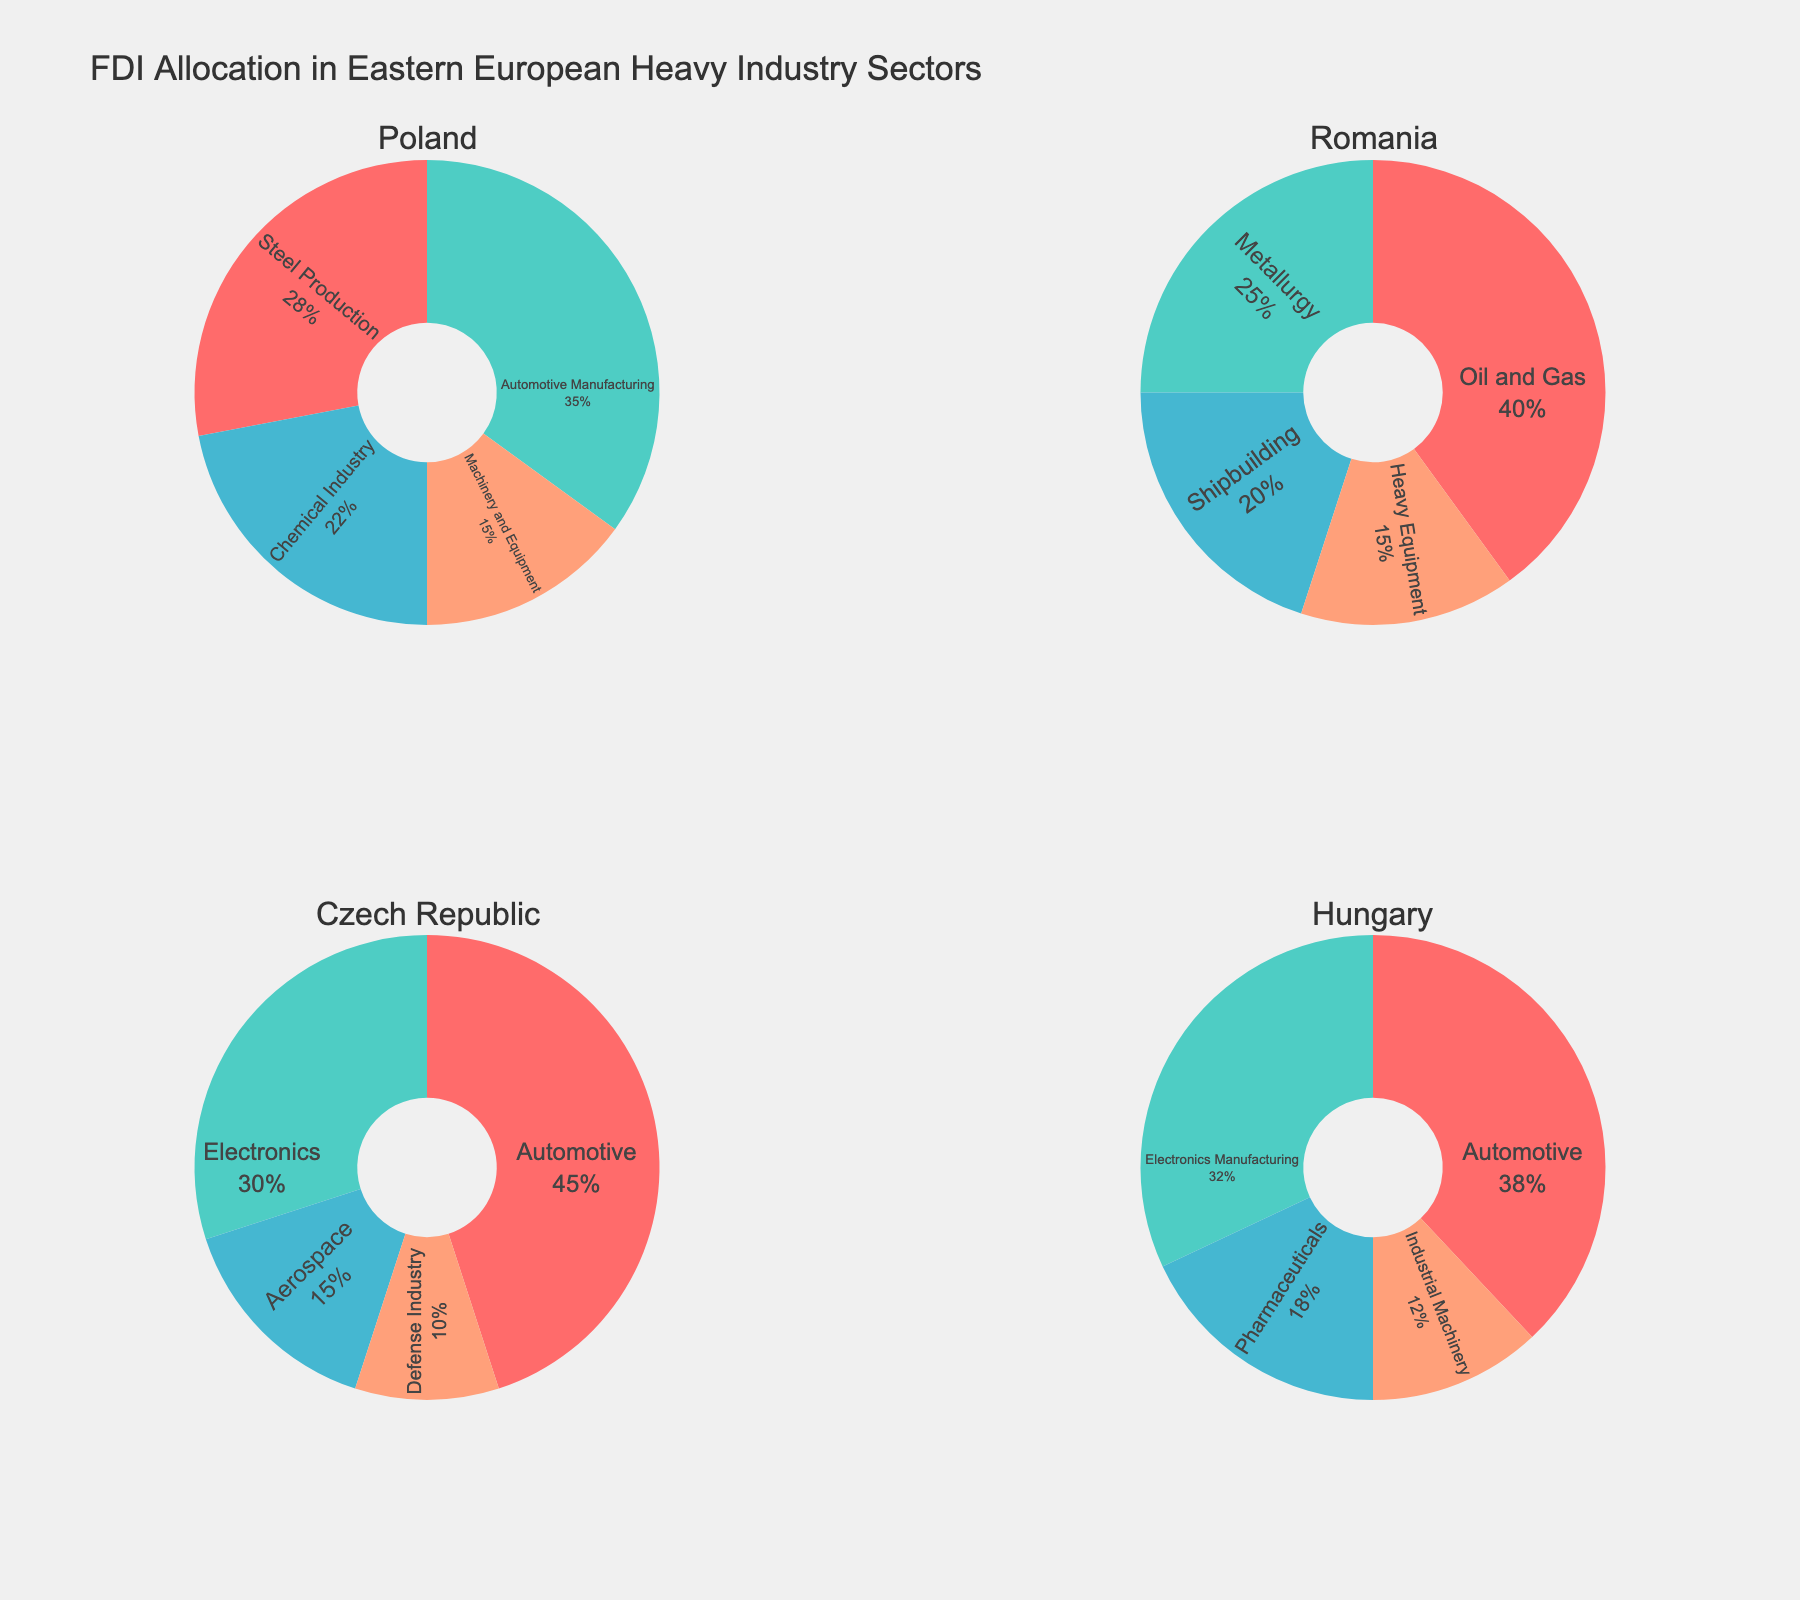What's the title of the figure? The title of the figure is written at the top center of the plot. It reads, "FDI Allocation in Eastern European Heavy Industry Sectors."
Answer: FDI Allocation in Eastern European Heavy Industry Sectors Which country has the highest allocation for a single sector, and what is the sector? By examining the pie charts, we observe that the Czech Republic has the highest allocation for the Automotive sector at 45%.
Answer: Czech Republic, Automotive What's the combined FDI allocation percentage for the Chemical Industry and Heavy Equipment sectors in Poland? We sum the percentages for the Chemical Industry (22%) and Heavy Equipment (15%) sectors in Poland. The combined allocation is 22% + 15% = 37%.
Answer: 37% Which sector receives the least FDI allocation in Hungary? By looking at the pie chart for Hungary, we notice that the Industrial Machinery sector receives the least FDI allocation at 12%.
Answer: Industrial Machinery How does the FDI allocation for the Automotive sector in the Czech Republic compare with that in Poland and Hungary? The FDI allocation in the Automotive sector is 45% in the Czech Republic, 35% in Poland, and 38% in Hungary. The Czech Republic has the highest allocation, followed by Hungary, and then Poland.
Answer: Highest in the Czech Republic, followed by Hungary, then Poland Which country has the most diversified foreign direct investment across its sectors? By observing the pie charts, we notice that Romania has the most balanced or diversified FDI distribution across its sectors, with no single sector dominating significantly.
Answer: Romania What is the difference in FDI allocation percentage between Oil and Gas in Romania and Electronics in the Czech Republic? The FDI allocation for Oil and Gas in Romania is 40%, and for Electronics in the Czech Republic, it is 30%. The difference is 40% - 30% = 10%.
Answer: 10% What percentage of FDI is allocated to the Defense Industry in the Czech Republic compared to Pharmaceuticals in Hungary? In the Czech Republic, the Defense Industry has an allocation of 10%, while in Hungary, Pharmaceuticals receive 18%.
Answer: 10% in the Czech Republic, 18% in Hungary If the FDI allocations for Shipbuilding and Heavy Equipment in Romania were combined, what would be the percentage allocation? Shipbuilding has an allocation of 20%, and Heavy Equipment has 15%. Combined, the total allocation would be 20% + 15% = 35%.
Answer: 35% Which country has the largest FDI allocation in a high-tech industry sector (Electronics, Aerospace, or Pharmaceuticals)? We notice that the Czech Republic has the largest FDI allocation in the high-tech sector with Electronics at 30%.
Answer: Czech Republic, Electronics 